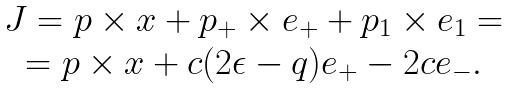<formula> <loc_0><loc_0><loc_500><loc_500>\begin{array} { c } { J } = { p } \times { x } + { p } _ { + } \times { e } _ { + } + { p } _ { 1 } \times { e } _ { 1 } = \\ = { p } \times { x } + c ( 2 \epsilon - q ) { e } _ { + } - 2 c { e } _ { - } . \end{array}</formula> 